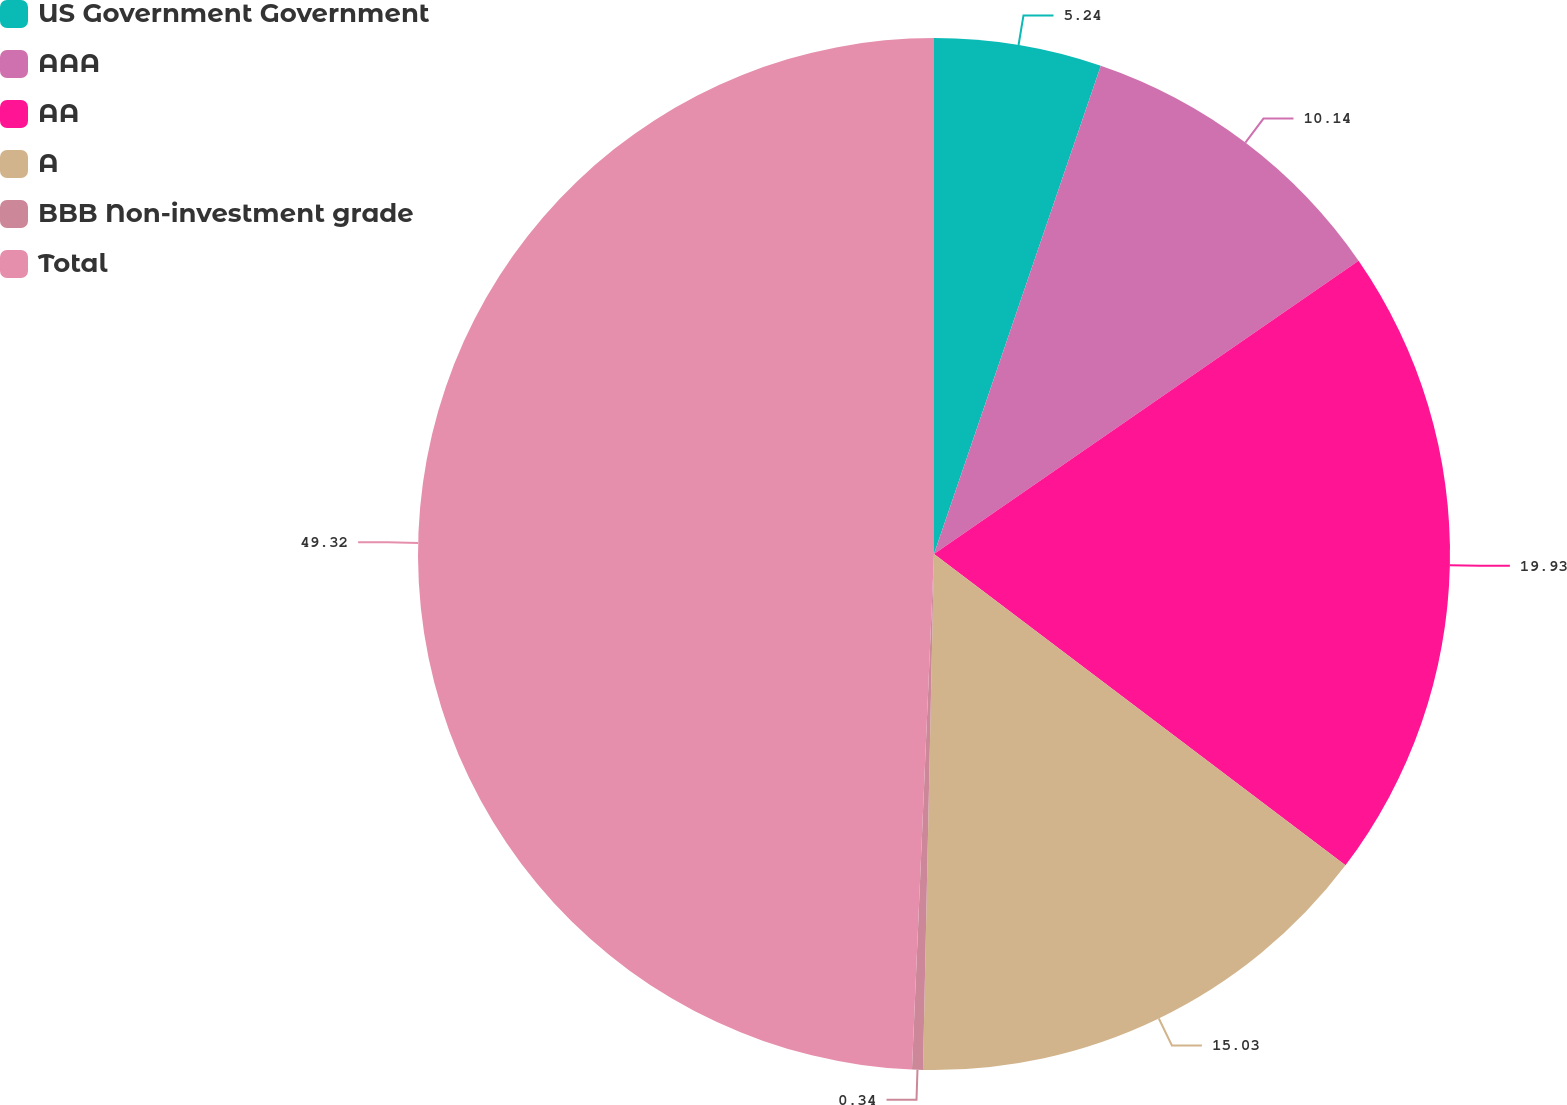<chart> <loc_0><loc_0><loc_500><loc_500><pie_chart><fcel>US Government Government<fcel>AAA<fcel>AA<fcel>A<fcel>BBB Non-investment grade<fcel>Total<nl><fcel>5.24%<fcel>10.14%<fcel>19.93%<fcel>15.03%<fcel>0.34%<fcel>49.32%<nl></chart> 